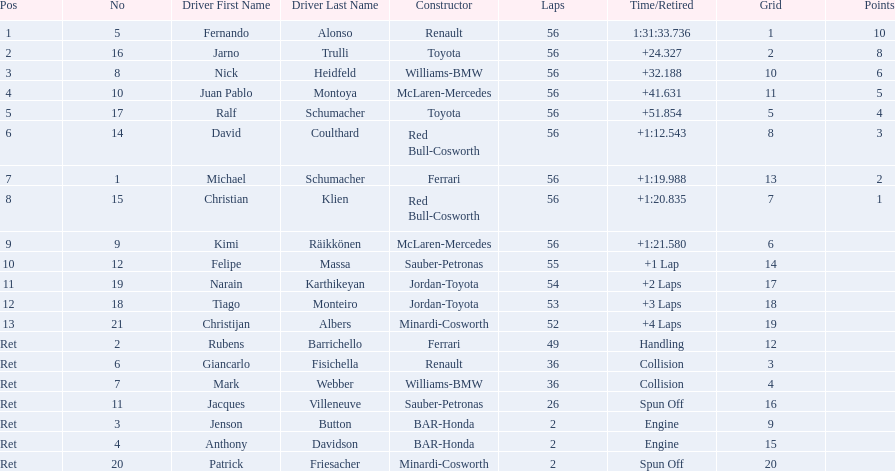Who raced during the 2005 malaysian grand prix? Fernando Alonso, Jarno Trulli, Nick Heidfeld, Juan Pablo Montoya, Ralf Schumacher, David Coulthard, Michael Schumacher, Christian Klien, Kimi Räikkönen, Felipe Massa, Narain Karthikeyan, Tiago Monteiro, Christijan Albers, Rubens Barrichello, Giancarlo Fisichella, Mark Webber, Jacques Villeneuve, Jenson Button, Anthony Davidson, Patrick Friesacher. Would you be able to parse every entry in this table? {'header': ['Pos', 'No', 'Driver First Name', 'Driver Last Name', 'Constructor', 'Laps', 'Time/Retired', 'Grid', 'Points'], 'rows': [['1', '5', 'Fernando', 'Alonso', 'Renault', '56', '1:31:33.736', '1', '10'], ['2', '16', 'Jarno', 'Trulli', 'Toyota', '56', '+24.327', '2', '8'], ['3', '8', 'Nick', 'Heidfeld', 'Williams-BMW', '56', '+32.188', '10', '6'], ['4', '10', 'Juan Pablo', 'Montoya', 'McLaren-Mercedes', '56', '+41.631', '11', '5'], ['5', '17', 'Ralf', 'Schumacher', 'Toyota', '56', '+51.854', '5', '4'], ['6', '14', 'David', 'Coulthard', 'Red Bull-Cosworth', '56', '+1:12.543', '8', '3'], ['7', '1', 'Michael', 'Schumacher', 'Ferrari', '56', '+1:19.988', '13', '2'], ['8', '15', 'Christian', 'Klien', 'Red Bull-Cosworth', '56', '+1:20.835', '7', '1'], ['9', '9', 'Kimi', 'Räikkönen', 'McLaren-Mercedes', '56', '+1:21.580', '6', ''], ['10', '12', 'Felipe', 'Massa', 'Sauber-Petronas', '55', '+1 Lap', '14', ''], ['11', '19', 'Narain', 'Karthikeyan', 'Jordan-Toyota', '54', '+2 Laps', '17', ''], ['12', '18', 'Tiago', 'Monteiro', 'Jordan-Toyota', '53', '+3 Laps', '18', ''], ['13', '21', 'Christijan', 'Albers', 'Minardi-Cosworth', '52', '+4 Laps', '19', ''], ['Ret', '2', 'Rubens', 'Barrichello', 'Ferrari', '49', 'Handling', '12', ''], ['Ret', '6', 'Giancarlo', 'Fisichella', 'Renault', '36', 'Collision', '3', ''], ['Ret', '7', 'Mark', 'Webber', 'Williams-BMW', '36', 'Collision', '4', ''], ['Ret', '11', 'Jacques', 'Villeneuve', 'Sauber-Petronas', '26', 'Spun Off', '16', ''], ['Ret', '3', 'Jenson', 'Button', 'BAR-Honda', '2', 'Engine', '9', ''], ['Ret', '4', 'Anthony', 'Davidson', 'BAR-Honda', '2', 'Engine', '15', ''], ['Ret', '20', 'Patrick', 'Friesacher', 'Minardi-Cosworth', '2', 'Spun Off', '20', '']]} What were their finishing times? 1:31:33.736, +24.327, +32.188, +41.631, +51.854, +1:12.543, +1:19.988, +1:20.835, +1:21.580, +1 Lap, +2 Laps, +3 Laps, +4 Laps, Handling, Collision, Collision, Spun Off, Engine, Engine, Spun Off. What was fernando alonso's finishing time? 1:31:33.736. 